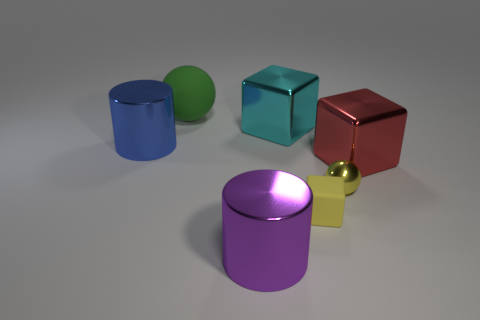There is a large shiny thing that is to the left of the large green sphere; is it the same shape as the matte object to the left of the big cyan cube?
Provide a succinct answer. No. There is a yellow thing that is the same shape as the large green thing; what size is it?
Provide a succinct answer. Small. How many big cylinders are made of the same material as the purple thing?
Your answer should be compact. 1. What material is the small cube?
Offer a terse response. Rubber. What shape is the metal thing behind the metal cylinder behind the tiny yellow cube?
Your response must be concise. Cube. The large thing that is in front of the large red metallic cube has what shape?
Offer a very short reply. Cylinder. How many shiny balls are the same color as the matte ball?
Provide a short and direct response. 0. What color is the small metal object?
Your answer should be very brief. Yellow. There is a ball on the left side of the small metallic sphere; what number of blue metal cylinders are in front of it?
Your response must be concise. 1. Do the yellow metal object and the matte object in front of the large green rubber ball have the same size?
Provide a short and direct response. Yes. 